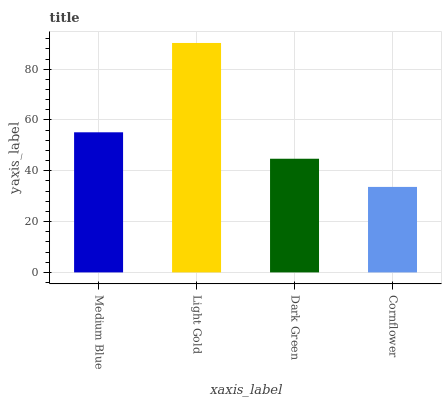Is Cornflower the minimum?
Answer yes or no. Yes. Is Light Gold the maximum?
Answer yes or no. Yes. Is Dark Green the minimum?
Answer yes or no. No. Is Dark Green the maximum?
Answer yes or no. No. Is Light Gold greater than Dark Green?
Answer yes or no. Yes. Is Dark Green less than Light Gold?
Answer yes or no. Yes. Is Dark Green greater than Light Gold?
Answer yes or no. No. Is Light Gold less than Dark Green?
Answer yes or no. No. Is Medium Blue the high median?
Answer yes or no. Yes. Is Dark Green the low median?
Answer yes or no. Yes. Is Dark Green the high median?
Answer yes or no. No. Is Light Gold the low median?
Answer yes or no. No. 